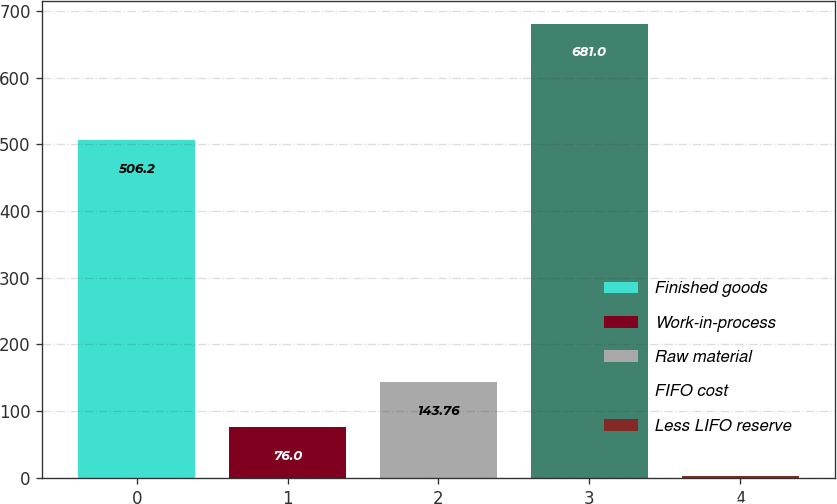Convert chart to OTSL. <chart><loc_0><loc_0><loc_500><loc_500><bar_chart><fcel>Finished goods<fcel>Work-in-process<fcel>Raw material<fcel>FIFO cost<fcel>Less LIFO reserve<nl><fcel>506.2<fcel>76<fcel>143.76<fcel>681<fcel>3.4<nl></chart> 